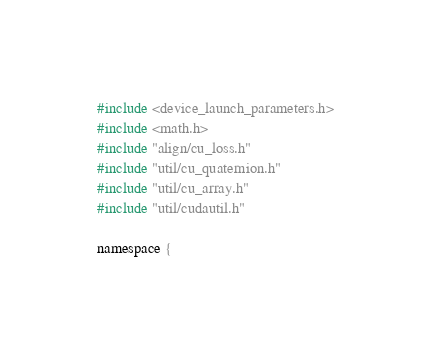<code> <loc_0><loc_0><loc_500><loc_500><_Cuda_>#include <device_launch_parameters.h>
#include <math.h>
#include "align/cu_loss.h"
#include "util/cu_quaternion.h"
#include "util/cu_array.h"
#include "util/cudautil.h"

namespace {</code> 